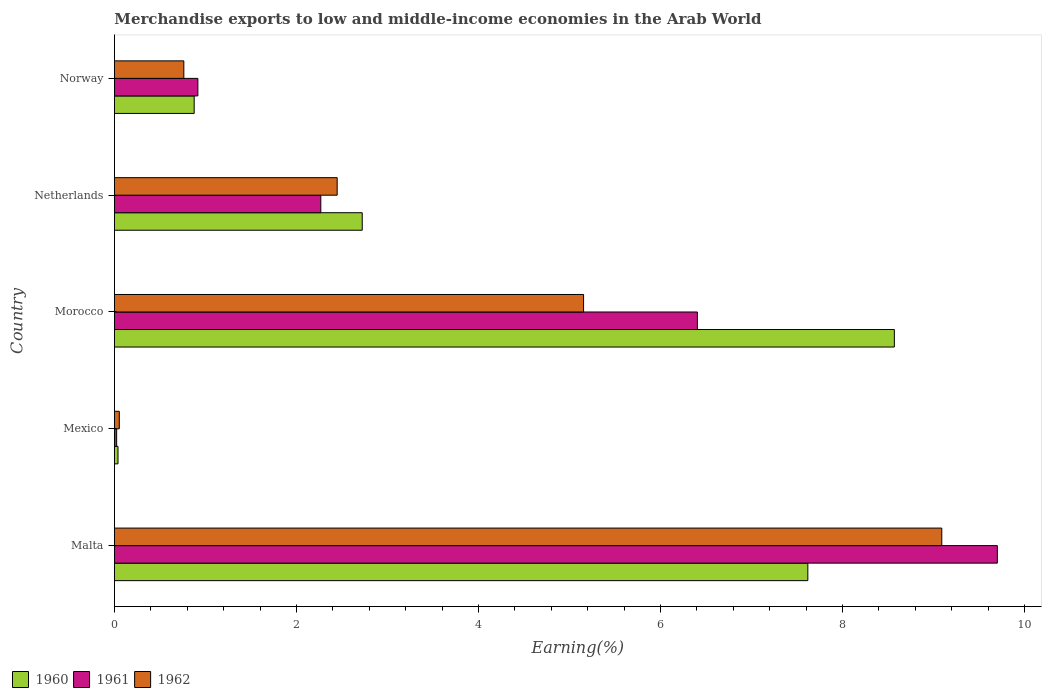How many different coloured bars are there?
Give a very brief answer. 3. Are the number of bars on each tick of the Y-axis equal?
Your answer should be compact. Yes. How many bars are there on the 2nd tick from the top?
Give a very brief answer. 3. What is the label of the 5th group of bars from the top?
Your answer should be compact. Malta. What is the percentage of amount earned from merchandise exports in 1960 in Mexico?
Offer a very short reply. 0.04. Across all countries, what is the maximum percentage of amount earned from merchandise exports in 1961?
Give a very brief answer. 9.7. Across all countries, what is the minimum percentage of amount earned from merchandise exports in 1962?
Offer a very short reply. 0.05. In which country was the percentage of amount earned from merchandise exports in 1962 maximum?
Ensure brevity in your answer.  Malta. What is the total percentage of amount earned from merchandise exports in 1962 in the graph?
Provide a succinct answer. 17.51. What is the difference between the percentage of amount earned from merchandise exports in 1962 in Morocco and that in Netherlands?
Give a very brief answer. 2.71. What is the difference between the percentage of amount earned from merchandise exports in 1960 in Netherlands and the percentage of amount earned from merchandise exports in 1961 in Norway?
Give a very brief answer. 1.81. What is the average percentage of amount earned from merchandise exports in 1961 per country?
Your answer should be compact. 3.86. What is the difference between the percentage of amount earned from merchandise exports in 1962 and percentage of amount earned from merchandise exports in 1961 in Mexico?
Keep it short and to the point. 0.03. In how many countries, is the percentage of amount earned from merchandise exports in 1962 greater than 0.4 %?
Provide a succinct answer. 4. What is the ratio of the percentage of amount earned from merchandise exports in 1960 in Mexico to that in Netherlands?
Provide a succinct answer. 0.01. What is the difference between the highest and the second highest percentage of amount earned from merchandise exports in 1960?
Ensure brevity in your answer.  0.95. What is the difference between the highest and the lowest percentage of amount earned from merchandise exports in 1962?
Keep it short and to the point. 9.04. In how many countries, is the percentage of amount earned from merchandise exports in 1961 greater than the average percentage of amount earned from merchandise exports in 1961 taken over all countries?
Your answer should be compact. 2. Is the sum of the percentage of amount earned from merchandise exports in 1960 in Morocco and Norway greater than the maximum percentage of amount earned from merchandise exports in 1961 across all countries?
Keep it short and to the point. No. What does the 3rd bar from the top in Netherlands represents?
Ensure brevity in your answer.  1960. What does the 3rd bar from the bottom in Malta represents?
Your response must be concise. 1962. How many bars are there?
Ensure brevity in your answer.  15. Are all the bars in the graph horizontal?
Offer a terse response. Yes. How many countries are there in the graph?
Offer a terse response. 5. What is the difference between two consecutive major ticks on the X-axis?
Your answer should be compact. 2. Does the graph contain any zero values?
Ensure brevity in your answer.  No. Does the graph contain grids?
Your response must be concise. No. How many legend labels are there?
Offer a very short reply. 3. How are the legend labels stacked?
Give a very brief answer. Horizontal. What is the title of the graph?
Make the answer very short. Merchandise exports to low and middle-income economies in the Arab World. Does "1961" appear as one of the legend labels in the graph?
Your response must be concise. Yes. What is the label or title of the X-axis?
Offer a very short reply. Earning(%). What is the label or title of the Y-axis?
Your answer should be compact. Country. What is the Earning(%) of 1960 in Malta?
Give a very brief answer. 7.62. What is the Earning(%) in 1961 in Malta?
Ensure brevity in your answer.  9.7. What is the Earning(%) in 1962 in Malta?
Keep it short and to the point. 9.09. What is the Earning(%) in 1960 in Mexico?
Offer a terse response. 0.04. What is the Earning(%) in 1961 in Mexico?
Provide a succinct answer. 0.02. What is the Earning(%) in 1962 in Mexico?
Your response must be concise. 0.05. What is the Earning(%) in 1960 in Morocco?
Your answer should be compact. 8.57. What is the Earning(%) in 1961 in Morocco?
Ensure brevity in your answer.  6.41. What is the Earning(%) in 1962 in Morocco?
Your answer should be very brief. 5.15. What is the Earning(%) in 1960 in Netherlands?
Ensure brevity in your answer.  2.72. What is the Earning(%) of 1961 in Netherlands?
Keep it short and to the point. 2.27. What is the Earning(%) of 1962 in Netherlands?
Ensure brevity in your answer.  2.45. What is the Earning(%) in 1960 in Norway?
Offer a very short reply. 0.88. What is the Earning(%) of 1961 in Norway?
Your answer should be compact. 0.92. What is the Earning(%) in 1962 in Norway?
Give a very brief answer. 0.76. Across all countries, what is the maximum Earning(%) of 1960?
Your answer should be very brief. 8.57. Across all countries, what is the maximum Earning(%) in 1961?
Provide a short and direct response. 9.7. Across all countries, what is the maximum Earning(%) in 1962?
Keep it short and to the point. 9.09. Across all countries, what is the minimum Earning(%) in 1960?
Your answer should be compact. 0.04. Across all countries, what is the minimum Earning(%) in 1961?
Provide a succinct answer. 0.02. Across all countries, what is the minimum Earning(%) of 1962?
Your answer should be very brief. 0.05. What is the total Earning(%) in 1960 in the graph?
Make the answer very short. 19.83. What is the total Earning(%) of 1961 in the graph?
Make the answer very short. 19.32. What is the total Earning(%) of 1962 in the graph?
Offer a terse response. 17.51. What is the difference between the Earning(%) in 1960 in Malta and that in Mexico?
Make the answer very short. 7.58. What is the difference between the Earning(%) of 1961 in Malta and that in Mexico?
Keep it short and to the point. 9.68. What is the difference between the Earning(%) of 1962 in Malta and that in Mexico?
Give a very brief answer. 9.04. What is the difference between the Earning(%) in 1960 in Malta and that in Morocco?
Your answer should be very brief. -0.95. What is the difference between the Earning(%) of 1961 in Malta and that in Morocco?
Offer a very short reply. 3.3. What is the difference between the Earning(%) in 1962 in Malta and that in Morocco?
Ensure brevity in your answer.  3.94. What is the difference between the Earning(%) in 1960 in Malta and that in Netherlands?
Keep it short and to the point. 4.9. What is the difference between the Earning(%) in 1961 in Malta and that in Netherlands?
Your answer should be compact. 7.43. What is the difference between the Earning(%) in 1962 in Malta and that in Netherlands?
Provide a short and direct response. 6.64. What is the difference between the Earning(%) of 1960 in Malta and that in Norway?
Keep it short and to the point. 6.74. What is the difference between the Earning(%) in 1961 in Malta and that in Norway?
Give a very brief answer. 8.78. What is the difference between the Earning(%) in 1962 in Malta and that in Norway?
Offer a very short reply. 8.33. What is the difference between the Earning(%) of 1960 in Mexico and that in Morocco?
Provide a short and direct response. -8.53. What is the difference between the Earning(%) in 1961 in Mexico and that in Morocco?
Your answer should be compact. -6.38. What is the difference between the Earning(%) of 1962 in Mexico and that in Morocco?
Provide a short and direct response. -5.1. What is the difference between the Earning(%) in 1960 in Mexico and that in Netherlands?
Your answer should be very brief. -2.68. What is the difference between the Earning(%) in 1961 in Mexico and that in Netherlands?
Offer a terse response. -2.24. What is the difference between the Earning(%) in 1962 in Mexico and that in Netherlands?
Provide a succinct answer. -2.39. What is the difference between the Earning(%) in 1960 in Mexico and that in Norway?
Offer a terse response. -0.84. What is the difference between the Earning(%) of 1961 in Mexico and that in Norway?
Give a very brief answer. -0.89. What is the difference between the Earning(%) of 1962 in Mexico and that in Norway?
Offer a terse response. -0.71. What is the difference between the Earning(%) in 1960 in Morocco and that in Netherlands?
Your answer should be compact. 5.85. What is the difference between the Earning(%) in 1961 in Morocco and that in Netherlands?
Give a very brief answer. 4.14. What is the difference between the Earning(%) in 1962 in Morocco and that in Netherlands?
Your response must be concise. 2.71. What is the difference between the Earning(%) in 1960 in Morocco and that in Norway?
Offer a very short reply. 7.69. What is the difference between the Earning(%) in 1961 in Morocco and that in Norway?
Provide a succinct answer. 5.49. What is the difference between the Earning(%) in 1962 in Morocco and that in Norway?
Offer a very short reply. 4.39. What is the difference between the Earning(%) in 1960 in Netherlands and that in Norway?
Provide a short and direct response. 1.85. What is the difference between the Earning(%) in 1961 in Netherlands and that in Norway?
Give a very brief answer. 1.35. What is the difference between the Earning(%) of 1962 in Netherlands and that in Norway?
Offer a very short reply. 1.68. What is the difference between the Earning(%) of 1960 in Malta and the Earning(%) of 1961 in Mexico?
Provide a short and direct response. 7.59. What is the difference between the Earning(%) of 1960 in Malta and the Earning(%) of 1962 in Mexico?
Offer a terse response. 7.57. What is the difference between the Earning(%) in 1961 in Malta and the Earning(%) in 1962 in Mexico?
Keep it short and to the point. 9.65. What is the difference between the Earning(%) in 1960 in Malta and the Earning(%) in 1961 in Morocco?
Make the answer very short. 1.21. What is the difference between the Earning(%) of 1960 in Malta and the Earning(%) of 1962 in Morocco?
Provide a succinct answer. 2.46. What is the difference between the Earning(%) in 1961 in Malta and the Earning(%) in 1962 in Morocco?
Give a very brief answer. 4.55. What is the difference between the Earning(%) in 1960 in Malta and the Earning(%) in 1961 in Netherlands?
Your response must be concise. 5.35. What is the difference between the Earning(%) of 1960 in Malta and the Earning(%) of 1962 in Netherlands?
Your answer should be very brief. 5.17. What is the difference between the Earning(%) in 1961 in Malta and the Earning(%) in 1962 in Netherlands?
Give a very brief answer. 7.25. What is the difference between the Earning(%) in 1960 in Malta and the Earning(%) in 1961 in Norway?
Ensure brevity in your answer.  6.7. What is the difference between the Earning(%) in 1960 in Malta and the Earning(%) in 1962 in Norway?
Ensure brevity in your answer.  6.86. What is the difference between the Earning(%) in 1961 in Malta and the Earning(%) in 1962 in Norway?
Provide a succinct answer. 8.94. What is the difference between the Earning(%) of 1960 in Mexico and the Earning(%) of 1961 in Morocco?
Make the answer very short. -6.37. What is the difference between the Earning(%) of 1960 in Mexico and the Earning(%) of 1962 in Morocco?
Give a very brief answer. -5.12. What is the difference between the Earning(%) in 1961 in Mexico and the Earning(%) in 1962 in Morocco?
Make the answer very short. -5.13. What is the difference between the Earning(%) of 1960 in Mexico and the Earning(%) of 1961 in Netherlands?
Your answer should be compact. -2.23. What is the difference between the Earning(%) of 1960 in Mexico and the Earning(%) of 1962 in Netherlands?
Provide a short and direct response. -2.41. What is the difference between the Earning(%) of 1961 in Mexico and the Earning(%) of 1962 in Netherlands?
Your answer should be compact. -2.42. What is the difference between the Earning(%) of 1960 in Mexico and the Earning(%) of 1961 in Norway?
Keep it short and to the point. -0.88. What is the difference between the Earning(%) in 1960 in Mexico and the Earning(%) in 1962 in Norway?
Make the answer very short. -0.72. What is the difference between the Earning(%) in 1961 in Mexico and the Earning(%) in 1962 in Norway?
Provide a short and direct response. -0.74. What is the difference between the Earning(%) of 1960 in Morocco and the Earning(%) of 1961 in Netherlands?
Your response must be concise. 6.3. What is the difference between the Earning(%) in 1960 in Morocco and the Earning(%) in 1962 in Netherlands?
Offer a very short reply. 6.12. What is the difference between the Earning(%) of 1961 in Morocco and the Earning(%) of 1962 in Netherlands?
Make the answer very short. 3.96. What is the difference between the Earning(%) in 1960 in Morocco and the Earning(%) in 1961 in Norway?
Your answer should be very brief. 7.65. What is the difference between the Earning(%) in 1960 in Morocco and the Earning(%) in 1962 in Norway?
Give a very brief answer. 7.81. What is the difference between the Earning(%) of 1961 in Morocco and the Earning(%) of 1962 in Norway?
Keep it short and to the point. 5.64. What is the difference between the Earning(%) of 1960 in Netherlands and the Earning(%) of 1961 in Norway?
Provide a succinct answer. 1.81. What is the difference between the Earning(%) of 1960 in Netherlands and the Earning(%) of 1962 in Norway?
Provide a short and direct response. 1.96. What is the difference between the Earning(%) of 1961 in Netherlands and the Earning(%) of 1962 in Norway?
Ensure brevity in your answer.  1.51. What is the average Earning(%) in 1960 per country?
Make the answer very short. 3.97. What is the average Earning(%) in 1961 per country?
Keep it short and to the point. 3.86. What is the average Earning(%) of 1962 per country?
Give a very brief answer. 3.5. What is the difference between the Earning(%) in 1960 and Earning(%) in 1961 in Malta?
Provide a succinct answer. -2.08. What is the difference between the Earning(%) in 1960 and Earning(%) in 1962 in Malta?
Your answer should be very brief. -1.47. What is the difference between the Earning(%) in 1961 and Earning(%) in 1962 in Malta?
Provide a succinct answer. 0.61. What is the difference between the Earning(%) in 1960 and Earning(%) in 1961 in Mexico?
Ensure brevity in your answer.  0.01. What is the difference between the Earning(%) in 1960 and Earning(%) in 1962 in Mexico?
Offer a very short reply. -0.01. What is the difference between the Earning(%) of 1961 and Earning(%) of 1962 in Mexico?
Your response must be concise. -0.03. What is the difference between the Earning(%) in 1960 and Earning(%) in 1961 in Morocco?
Provide a short and direct response. 2.16. What is the difference between the Earning(%) in 1960 and Earning(%) in 1962 in Morocco?
Give a very brief answer. 3.41. What is the difference between the Earning(%) of 1961 and Earning(%) of 1962 in Morocco?
Offer a very short reply. 1.25. What is the difference between the Earning(%) of 1960 and Earning(%) of 1961 in Netherlands?
Offer a terse response. 0.46. What is the difference between the Earning(%) in 1960 and Earning(%) in 1962 in Netherlands?
Keep it short and to the point. 0.28. What is the difference between the Earning(%) in 1961 and Earning(%) in 1962 in Netherlands?
Keep it short and to the point. -0.18. What is the difference between the Earning(%) of 1960 and Earning(%) of 1961 in Norway?
Ensure brevity in your answer.  -0.04. What is the difference between the Earning(%) in 1960 and Earning(%) in 1962 in Norway?
Make the answer very short. 0.11. What is the difference between the Earning(%) of 1961 and Earning(%) of 1962 in Norway?
Give a very brief answer. 0.15. What is the ratio of the Earning(%) of 1960 in Malta to that in Mexico?
Ensure brevity in your answer.  194.13. What is the ratio of the Earning(%) of 1961 in Malta to that in Mexico?
Provide a short and direct response. 400.48. What is the ratio of the Earning(%) in 1962 in Malta to that in Mexico?
Your answer should be compact. 169.22. What is the ratio of the Earning(%) of 1960 in Malta to that in Morocco?
Provide a short and direct response. 0.89. What is the ratio of the Earning(%) in 1961 in Malta to that in Morocco?
Ensure brevity in your answer.  1.51. What is the ratio of the Earning(%) in 1962 in Malta to that in Morocco?
Your answer should be compact. 1.76. What is the ratio of the Earning(%) of 1960 in Malta to that in Netherlands?
Ensure brevity in your answer.  2.8. What is the ratio of the Earning(%) in 1961 in Malta to that in Netherlands?
Provide a succinct answer. 4.28. What is the ratio of the Earning(%) in 1962 in Malta to that in Netherlands?
Provide a short and direct response. 3.71. What is the ratio of the Earning(%) of 1960 in Malta to that in Norway?
Offer a very short reply. 8.69. What is the ratio of the Earning(%) of 1961 in Malta to that in Norway?
Ensure brevity in your answer.  10.58. What is the ratio of the Earning(%) in 1962 in Malta to that in Norway?
Provide a short and direct response. 11.92. What is the ratio of the Earning(%) in 1960 in Mexico to that in Morocco?
Give a very brief answer. 0. What is the ratio of the Earning(%) of 1961 in Mexico to that in Morocco?
Your answer should be very brief. 0. What is the ratio of the Earning(%) in 1962 in Mexico to that in Morocco?
Make the answer very short. 0.01. What is the ratio of the Earning(%) of 1960 in Mexico to that in Netherlands?
Your response must be concise. 0.01. What is the ratio of the Earning(%) in 1961 in Mexico to that in Netherlands?
Your response must be concise. 0.01. What is the ratio of the Earning(%) in 1962 in Mexico to that in Netherlands?
Offer a very short reply. 0.02. What is the ratio of the Earning(%) of 1960 in Mexico to that in Norway?
Your response must be concise. 0.04. What is the ratio of the Earning(%) of 1961 in Mexico to that in Norway?
Provide a short and direct response. 0.03. What is the ratio of the Earning(%) in 1962 in Mexico to that in Norway?
Your answer should be compact. 0.07. What is the ratio of the Earning(%) in 1960 in Morocco to that in Netherlands?
Provide a short and direct response. 3.15. What is the ratio of the Earning(%) of 1961 in Morocco to that in Netherlands?
Make the answer very short. 2.82. What is the ratio of the Earning(%) in 1962 in Morocco to that in Netherlands?
Offer a very short reply. 2.11. What is the ratio of the Earning(%) of 1960 in Morocco to that in Norway?
Make the answer very short. 9.78. What is the ratio of the Earning(%) in 1961 in Morocco to that in Norway?
Give a very brief answer. 6.99. What is the ratio of the Earning(%) of 1962 in Morocco to that in Norway?
Your answer should be very brief. 6.76. What is the ratio of the Earning(%) in 1960 in Netherlands to that in Norway?
Ensure brevity in your answer.  3.11. What is the ratio of the Earning(%) in 1961 in Netherlands to that in Norway?
Give a very brief answer. 2.47. What is the ratio of the Earning(%) in 1962 in Netherlands to that in Norway?
Keep it short and to the point. 3.21. What is the difference between the highest and the second highest Earning(%) of 1960?
Your response must be concise. 0.95. What is the difference between the highest and the second highest Earning(%) of 1961?
Make the answer very short. 3.3. What is the difference between the highest and the second highest Earning(%) in 1962?
Keep it short and to the point. 3.94. What is the difference between the highest and the lowest Earning(%) of 1960?
Provide a short and direct response. 8.53. What is the difference between the highest and the lowest Earning(%) of 1961?
Give a very brief answer. 9.68. What is the difference between the highest and the lowest Earning(%) in 1962?
Offer a terse response. 9.04. 